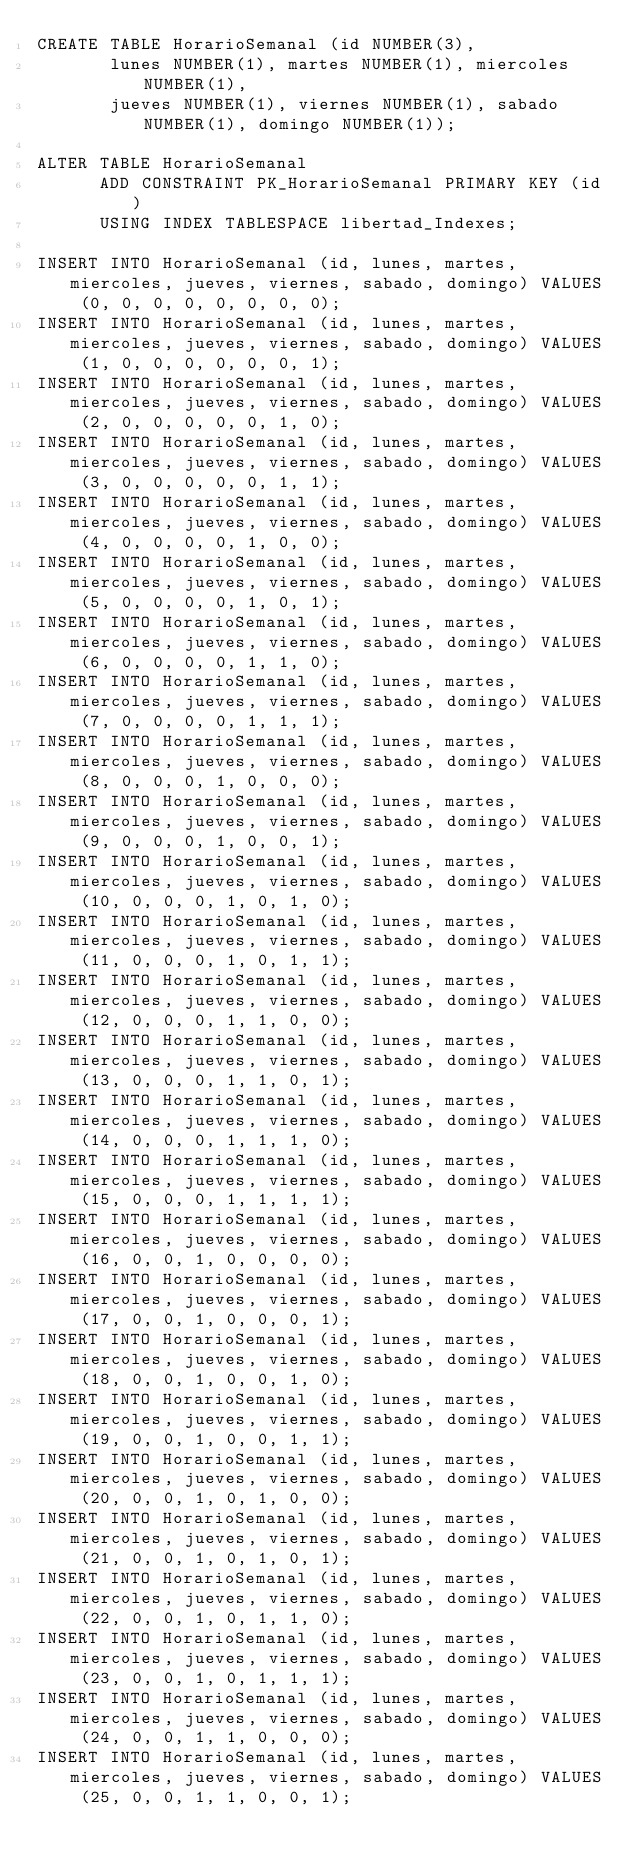Convert code to text. <code><loc_0><loc_0><loc_500><loc_500><_SQL_>CREATE TABLE HorarioSemanal (id NUMBER(3),
       lunes NUMBER(1), martes NUMBER(1), miercoles NUMBER(1),
       jueves NUMBER(1), viernes NUMBER(1), sabado NUMBER(1), domingo NUMBER(1));
       
ALTER TABLE HorarioSemanal
      ADD CONSTRAINT PK_HorarioSemanal PRIMARY KEY (id)
      USING INDEX TABLESPACE libertad_Indexes;

INSERT INTO HorarioSemanal (id, lunes, martes, miercoles, jueves, viernes, sabado, domingo) VALUES (0, 0, 0, 0, 0, 0, 0, 0);
INSERT INTO HorarioSemanal (id, lunes, martes, miercoles, jueves, viernes, sabado, domingo) VALUES (1, 0, 0, 0, 0, 0, 0, 1);
INSERT INTO HorarioSemanal (id, lunes, martes, miercoles, jueves, viernes, sabado, domingo) VALUES (2, 0, 0, 0, 0, 0, 1, 0);
INSERT INTO HorarioSemanal (id, lunes, martes, miercoles, jueves, viernes, sabado, domingo) VALUES (3, 0, 0, 0, 0, 0, 1, 1);
INSERT INTO HorarioSemanal (id, lunes, martes, miercoles, jueves, viernes, sabado, domingo) VALUES (4, 0, 0, 0, 0, 1, 0, 0);
INSERT INTO HorarioSemanal (id, lunes, martes, miercoles, jueves, viernes, sabado, domingo) VALUES (5, 0, 0, 0, 0, 1, 0, 1);
INSERT INTO HorarioSemanal (id, lunes, martes, miercoles, jueves, viernes, sabado, domingo) VALUES (6, 0, 0, 0, 0, 1, 1, 0);
INSERT INTO HorarioSemanal (id, lunes, martes, miercoles, jueves, viernes, sabado, domingo) VALUES (7, 0, 0, 0, 0, 1, 1, 1);
INSERT INTO HorarioSemanal (id, lunes, martes, miercoles, jueves, viernes, sabado, domingo) VALUES (8, 0, 0, 0, 1, 0, 0, 0);
INSERT INTO HorarioSemanal (id, lunes, martes, miercoles, jueves, viernes, sabado, domingo) VALUES (9, 0, 0, 0, 1, 0, 0, 1);
INSERT INTO HorarioSemanal (id, lunes, martes, miercoles, jueves, viernes, sabado, domingo) VALUES (10, 0, 0, 0, 1, 0, 1, 0);
INSERT INTO HorarioSemanal (id, lunes, martes, miercoles, jueves, viernes, sabado, domingo) VALUES (11, 0, 0, 0, 1, 0, 1, 1);
INSERT INTO HorarioSemanal (id, lunes, martes, miercoles, jueves, viernes, sabado, domingo) VALUES (12, 0, 0, 0, 1, 1, 0, 0);
INSERT INTO HorarioSemanal (id, lunes, martes, miercoles, jueves, viernes, sabado, domingo) VALUES (13, 0, 0, 0, 1, 1, 0, 1);
INSERT INTO HorarioSemanal (id, lunes, martes, miercoles, jueves, viernes, sabado, domingo) VALUES (14, 0, 0, 0, 1, 1, 1, 0);
INSERT INTO HorarioSemanal (id, lunes, martes, miercoles, jueves, viernes, sabado, domingo) VALUES (15, 0, 0, 0, 1, 1, 1, 1);
INSERT INTO HorarioSemanal (id, lunes, martes, miercoles, jueves, viernes, sabado, domingo) VALUES (16, 0, 0, 1, 0, 0, 0, 0);
INSERT INTO HorarioSemanal (id, lunes, martes, miercoles, jueves, viernes, sabado, domingo) VALUES (17, 0, 0, 1, 0, 0, 0, 1);
INSERT INTO HorarioSemanal (id, lunes, martes, miercoles, jueves, viernes, sabado, domingo) VALUES (18, 0, 0, 1, 0, 0, 1, 0);
INSERT INTO HorarioSemanal (id, lunes, martes, miercoles, jueves, viernes, sabado, domingo) VALUES (19, 0, 0, 1, 0, 0, 1, 1);
INSERT INTO HorarioSemanal (id, lunes, martes, miercoles, jueves, viernes, sabado, domingo) VALUES (20, 0, 0, 1, 0, 1, 0, 0);
INSERT INTO HorarioSemanal (id, lunes, martes, miercoles, jueves, viernes, sabado, domingo) VALUES (21, 0, 0, 1, 0, 1, 0, 1);
INSERT INTO HorarioSemanal (id, lunes, martes, miercoles, jueves, viernes, sabado, domingo) VALUES (22, 0, 0, 1, 0, 1, 1, 0);
INSERT INTO HorarioSemanal (id, lunes, martes, miercoles, jueves, viernes, sabado, domingo) VALUES (23, 0, 0, 1, 0, 1, 1, 1);
INSERT INTO HorarioSemanal (id, lunes, martes, miercoles, jueves, viernes, sabado, domingo) VALUES (24, 0, 0, 1, 1, 0, 0, 0);
INSERT INTO HorarioSemanal (id, lunes, martes, miercoles, jueves, viernes, sabado, domingo) VALUES (25, 0, 0, 1, 1, 0, 0, 1);</code> 